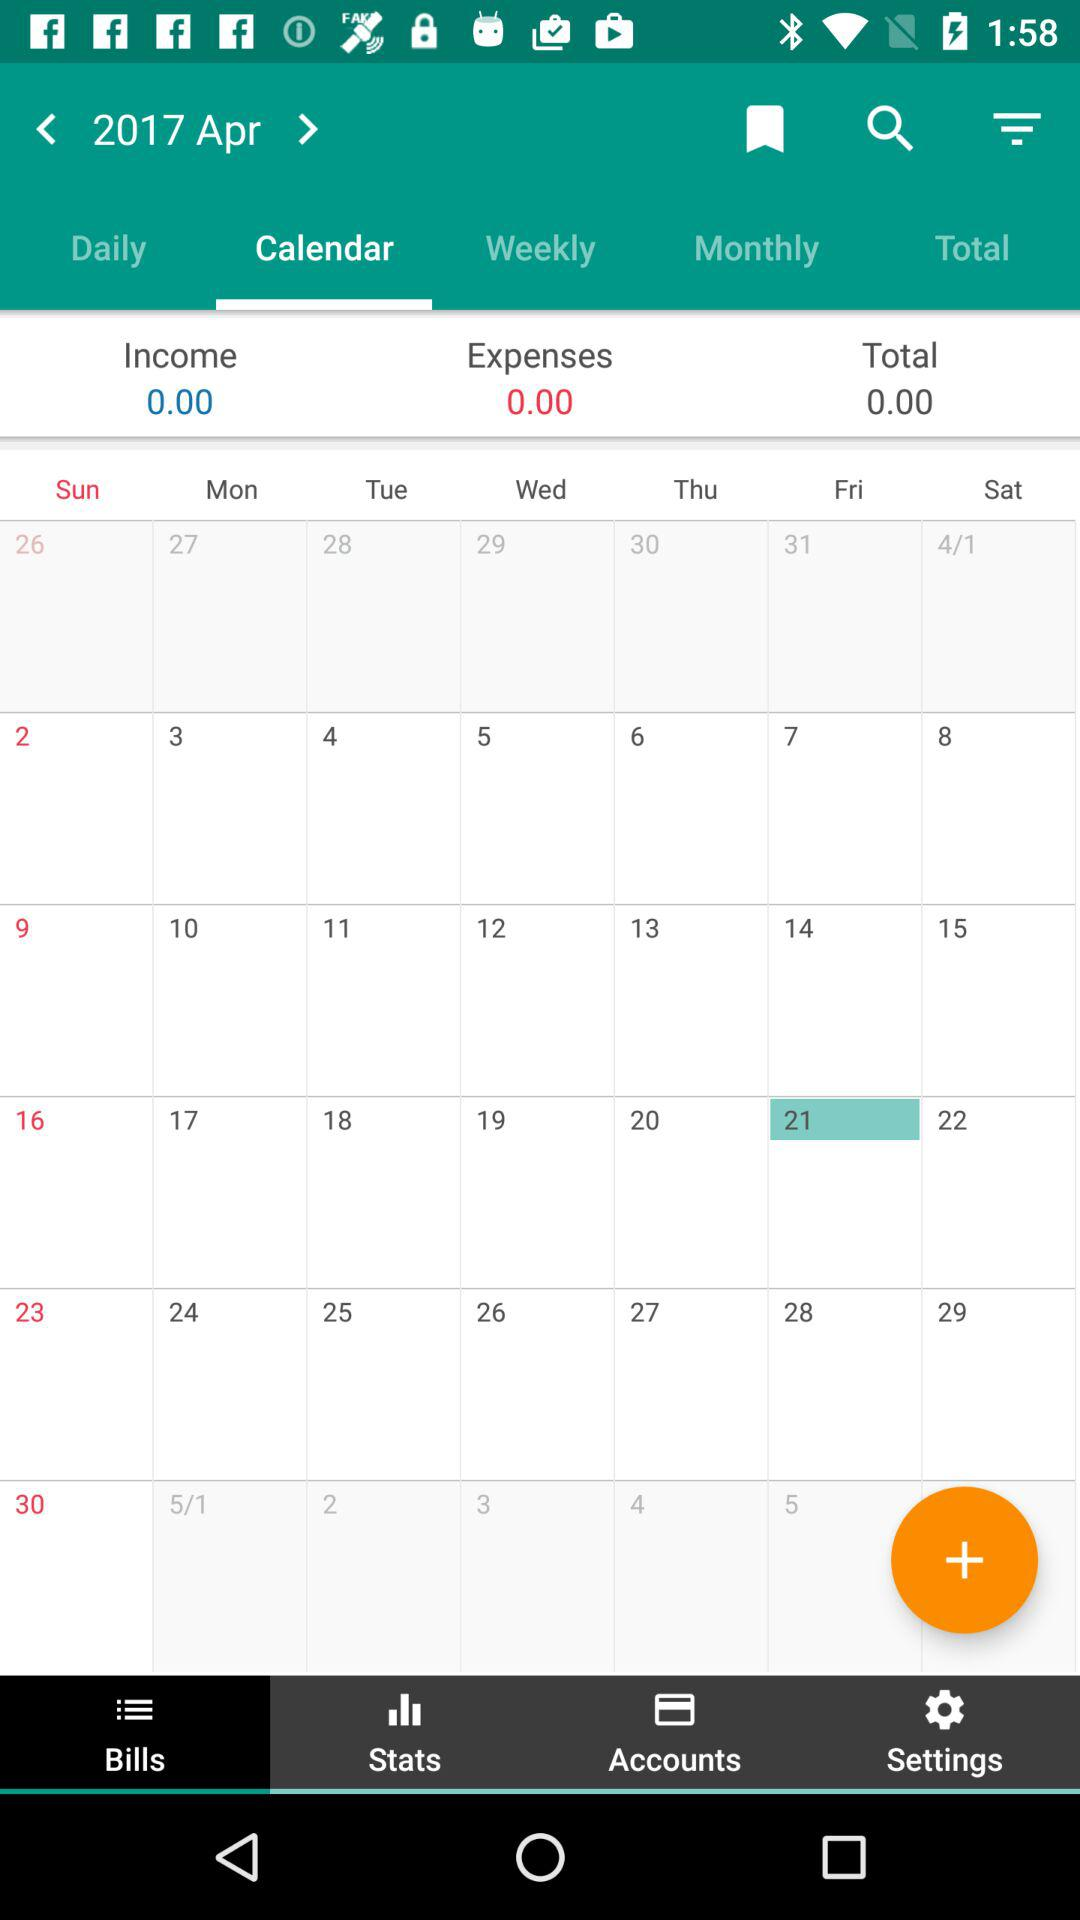What is the income shown in the "Calendar"? The income shown in the "Calendar" is 0.00. 